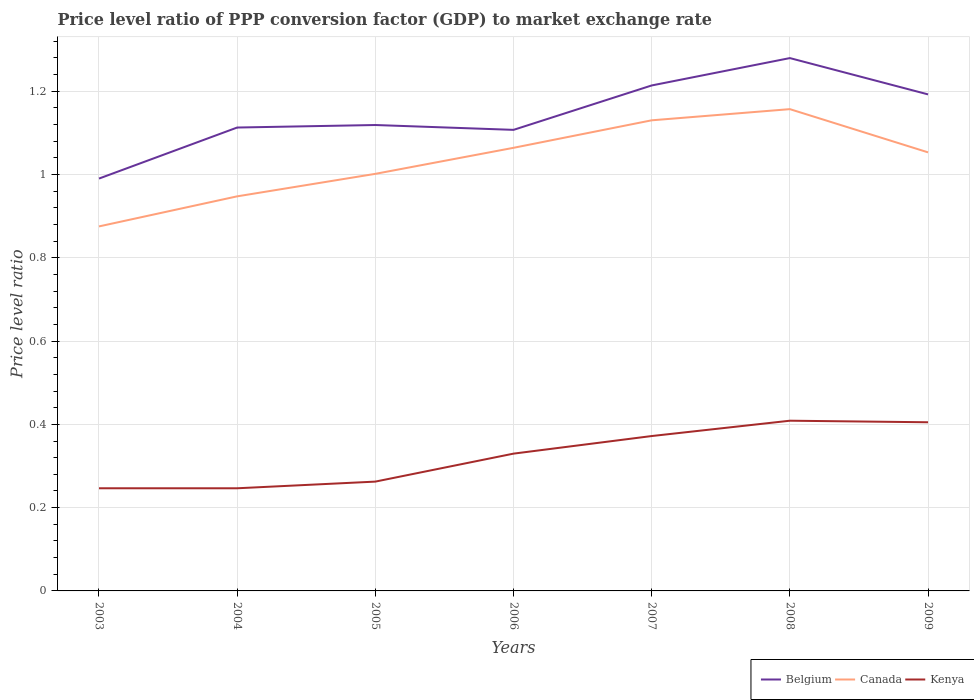Does the line corresponding to Kenya intersect with the line corresponding to Canada?
Offer a terse response. No. Is the number of lines equal to the number of legend labels?
Make the answer very short. Yes. Across all years, what is the maximum price level ratio in Canada?
Make the answer very short. 0.88. What is the total price level ratio in Belgium in the graph?
Your answer should be compact. -0.1. What is the difference between the highest and the second highest price level ratio in Kenya?
Provide a succinct answer. 0.16. Is the price level ratio in Canada strictly greater than the price level ratio in Kenya over the years?
Provide a succinct answer. No. How many years are there in the graph?
Offer a very short reply. 7. What is the difference between two consecutive major ticks on the Y-axis?
Keep it short and to the point. 0.2. Does the graph contain any zero values?
Keep it short and to the point. No. Does the graph contain grids?
Make the answer very short. Yes. How are the legend labels stacked?
Offer a terse response. Horizontal. What is the title of the graph?
Make the answer very short. Price level ratio of PPP conversion factor (GDP) to market exchange rate. What is the label or title of the Y-axis?
Make the answer very short. Price level ratio. What is the Price level ratio of Belgium in 2003?
Your response must be concise. 0.99. What is the Price level ratio in Canada in 2003?
Offer a terse response. 0.88. What is the Price level ratio in Kenya in 2003?
Provide a succinct answer. 0.25. What is the Price level ratio of Belgium in 2004?
Provide a succinct answer. 1.11. What is the Price level ratio of Canada in 2004?
Keep it short and to the point. 0.95. What is the Price level ratio of Kenya in 2004?
Make the answer very short. 0.25. What is the Price level ratio of Belgium in 2005?
Make the answer very short. 1.12. What is the Price level ratio in Canada in 2005?
Provide a short and direct response. 1. What is the Price level ratio in Kenya in 2005?
Provide a succinct answer. 0.26. What is the Price level ratio in Belgium in 2006?
Your response must be concise. 1.11. What is the Price level ratio of Canada in 2006?
Provide a succinct answer. 1.06. What is the Price level ratio of Kenya in 2006?
Give a very brief answer. 0.33. What is the Price level ratio in Belgium in 2007?
Your response must be concise. 1.21. What is the Price level ratio in Canada in 2007?
Offer a terse response. 1.13. What is the Price level ratio of Kenya in 2007?
Offer a very short reply. 0.37. What is the Price level ratio in Belgium in 2008?
Your answer should be very brief. 1.28. What is the Price level ratio in Canada in 2008?
Offer a very short reply. 1.16. What is the Price level ratio in Kenya in 2008?
Offer a terse response. 0.41. What is the Price level ratio of Belgium in 2009?
Make the answer very short. 1.19. What is the Price level ratio in Canada in 2009?
Give a very brief answer. 1.05. What is the Price level ratio in Kenya in 2009?
Keep it short and to the point. 0.4. Across all years, what is the maximum Price level ratio of Belgium?
Make the answer very short. 1.28. Across all years, what is the maximum Price level ratio in Canada?
Keep it short and to the point. 1.16. Across all years, what is the maximum Price level ratio of Kenya?
Your answer should be compact. 0.41. Across all years, what is the minimum Price level ratio of Belgium?
Give a very brief answer. 0.99. Across all years, what is the minimum Price level ratio of Canada?
Make the answer very short. 0.88. Across all years, what is the minimum Price level ratio in Kenya?
Provide a succinct answer. 0.25. What is the total Price level ratio of Belgium in the graph?
Provide a short and direct response. 8.01. What is the total Price level ratio in Canada in the graph?
Give a very brief answer. 7.23. What is the total Price level ratio of Kenya in the graph?
Offer a terse response. 2.27. What is the difference between the Price level ratio of Belgium in 2003 and that in 2004?
Make the answer very short. -0.12. What is the difference between the Price level ratio in Canada in 2003 and that in 2004?
Ensure brevity in your answer.  -0.07. What is the difference between the Price level ratio in Belgium in 2003 and that in 2005?
Keep it short and to the point. -0.13. What is the difference between the Price level ratio in Canada in 2003 and that in 2005?
Give a very brief answer. -0.13. What is the difference between the Price level ratio in Kenya in 2003 and that in 2005?
Your answer should be very brief. -0.02. What is the difference between the Price level ratio in Belgium in 2003 and that in 2006?
Provide a short and direct response. -0.12. What is the difference between the Price level ratio in Canada in 2003 and that in 2006?
Your response must be concise. -0.19. What is the difference between the Price level ratio of Kenya in 2003 and that in 2006?
Keep it short and to the point. -0.08. What is the difference between the Price level ratio in Belgium in 2003 and that in 2007?
Your answer should be very brief. -0.22. What is the difference between the Price level ratio in Canada in 2003 and that in 2007?
Keep it short and to the point. -0.25. What is the difference between the Price level ratio in Kenya in 2003 and that in 2007?
Your answer should be very brief. -0.13. What is the difference between the Price level ratio of Belgium in 2003 and that in 2008?
Make the answer very short. -0.29. What is the difference between the Price level ratio in Canada in 2003 and that in 2008?
Offer a very short reply. -0.28. What is the difference between the Price level ratio in Kenya in 2003 and that in 2008?
Your response must be concise. -0.16. What is the difference between the Price level ratio in Belgium in 2003 and that in 2009?
Your response must be concise. -0.2. What is the difference between the Price level ratio in Canada in 2003 and that in 2009?
Provide a succinct answer. -0.18. What is the difference between the Price level ratio of Kenya in 2003 and that in 2009?
Provide a succinct answer. -0.16. What is the difference between the Price level ratio in Belgium in 2004 and that in 2005?
Offer a terse response. -0.01. What is the difference between the Price level ratio in Canada in 2004 and that in 2005?
Your response must be concise. -0.05. What is the difference between the Price level ratio of Kenya in 2004 and that in 2005?
Your response must be concise. -0.02. What is the difference between the Price level ratio in Belgium in 2004 and that in 2006?
Provide a succinct answer. 0.01. What is the difference between the Price level ratio in Canada in 2004 and that in 2006?
Offer a very short reply. -0.12. What is the difference between the Price level ratio in Kenya in 2004 and that in 2006?
Ensure brevity in your answer.  -0.08. What is the difference between the Price level ratio in Belgium in 2004 and that in 2007?
Your answer should be compact. -0.1. What is the difference between the Price level ratio of Canada in 2004 and that in 2007?
Offer a very short reply. -0.18. What is the difference between the Price level ratio of Kenya in 2004 and that in 2007?
Your response must be concise. -0.13. What is the difference between the Price level ratio of Belgium in 2004 and that in 2008?
Your response must be concise. -0.17. What is the difference between the Price level ratio in Canada in 2004 and that in 2008?
Keep it short and to the point. -0.21. What is the difference between the Price level ratio in Kenya in 2004 and that in 2008?
Give a very brief answer. -0.16. What is the difference between the Price level ratio of Belgium in 2004 and that in 2009?
Give a very brief answer. -0.08. What is the difference between the Price level ratio in Canada in 2004 and that in 2009?
Offer a very short reply. -0.11. What is the difference between the Price level ratio in Kenya in 2004 and that in 2009?
Make the answer very short. -0.16. What is the difference between the Price level ratio in Belgium in 2005 and that in 2006?
Provide a short and direct response. 0.01. What is the difference between the Price level ratio of Canada in 2005 and that in 2006?
Keep it short and to the point. -0.06. What is the difference between the Price level ratio of Kenya in 2005 and that in 2006?
Provide a short and direct response. -0.07. What is the difference between the Price level ratio of Belgium in 2005 and that in 2007?
Provide a succinct answer. -0.1. What is the difference between the Price level ratio in Canada in 2005 and that in 2007?
Provide a short and direct response. -0.13. What is the difference between the Price level ratio of Kenya in 2005 and that in 2007?
Provide a short and direct response. -0.11. What is the difference between the Price level ratio of Belgium in 2005 and that in 2008?
Provide a short and direct response. -0.16. What is the difference between the Price level ratio in Canada in 2005 and that in 2008?
Your answer should be very brief. -0.16. What is the difference between the Price level ratio of Kenya in 2005 and that in 2008?
Your response must be concise. -0.15. What is the difference between the Price level ratio of Belgium in 2005 and that in 2009?
Your response must be concise. -0.07. What is the difference between the Price level ratio of Canada in 2005 and that in 2009?
Make the answer very short. -0.05. What is the difference between the Price level ratio of Kenya in 2005 and that in 2009?
Keep it short and to the point. -0.14. What is the difference between the Price level ratio in Belgium in 2006 and that in 2007?
Your answer should be compact. -0.11. What is the difference between the Price level ratio of Canada in 2006 and that in 2007?
Your answer should be very brief. -0.07. What is the difference between the Price level ratio in Kenya in 2006 and that in 2007?
Offer a terse response. -0.04. What is the difference between the Price level ratio in Belgium in 2006 and that in 2008?
Make the answer very short. -0.17. What is the difference between the Price level ratio in Canada in 2006 and that in 2008?
Keep it short and to the point. -0.09. What is the difference between the Price level ratio of Kenya in 2006 and that in 2008?
Make the answer very short. -0.08. What is the difference between the Price level ratio in Belgium in 2006 and that in 2009?
Provide a short and direct response. -0.09. What is the difference between the Price level ratio in Canada in 2006 and that in 2009?
Provide a succinct answer. 0.01. What is the difference between the Price level ratio in Kenya in 2006 and that in 2009?
Provide a succinct answer. -0.08. What is the difference between the Price level ratio in Belgium in 2007 and that in 2008?
Make the answer very short. -0.07. What is the difference between the Price level ratio of Canada in 2007 and that in 2008?
Keep it short and to the point. -0.03. What is the difference between the Price level ratio of Kenya in 2007 and that in 2008?
Give a very brief answer. -0.04. What is the difference between the Price level ratio of Belgium in 2007 and that in 2009?
Give a very brief answer. 0.02. What is the difference between the Price level ratio in Canada in 2007 and that in 2009?
Provide a succinct answer. 0.08. What is the difference between the Price level ratio of Kenya in 2007 and that in 2009?
Provide a succinct answer. -0.03. What is the difference between the Price level ratio of Belgium in 2008 and that in 2009?
Provide a short and direct response. 0.09. What is the difference between the Price level ratio in Canada in 2008 and that in 2009?
Your answer should be very brief. 0.1. What is the difference between the Price level ratio of Kenya in 2008 and that in 2009?
Offer a very short reply. 0. What is the difference between the Price level ratio of Belgium in 2003 and the Price level ratio of Canada in 2004?
Keep it short and to the point. 0.04. What is the difference between the Price level ratio of Belgium in 2003 and the Price level ratio of Kenya in 2004?
Provide a succinct answer. 0.74. What is the difference between the Price level ratio in Canada in 2003 and the Price level ratio in Kenya in 2004?
Make the answer very short. 0.63. What is the difference between the Price level ratio of Belgium in 2003 and the Price level ratio of Canada in 2005?
Offer a terse response. -0.01. What is the difference between the Price level ratio in Belgium in 2003 and the Price level ratio in Kenya in 2005?
Provide a succinct answer. 0.73. What is the difference between the Price level ratio in Canada in 2003 and the Price level ratio in Kenya in 2005?
Offer a terse response. 0.61. What is the difference between the Price level ratio of Belgium in 2003 and the Price level ratio of Canada in 2006?
Offer a terse response. -0.07. What is the difference between the Price level ratio of Belgium in 2003 and the Price level ratio of Kenya in 2006?
Offer a terse response. 0.66. What is the difference between the Price level ratio in Canada in 2003 and the Price level ratio in Kenya in 2006?
Your response must be concise. 0.55. What is the difference between the Price level ratio in Belgium in 2003 and the Price level ratio in Canada in 2007?
Your answer should be very brief. -0.14. What is the difference between the Price level ratio of Belgium in 2003 and the Price level ratio of Kenya in 2007?
Your answer should be very brief. 0.62. What is the difference between the Price level ratio of Canada in 2003 and the Price level ratio of Kenya in 2007?
Your response must be concise. 0.5. What is the difference between the Price level ratio in Belgium in 2003 and the Price level ratio in Canada in 2008?
Your answer should be compact. -0.17. What is the difference between the Price level ratio of Belgium in 2003 and the Price level ratio of Kenya in 2008?
Your answer should be very brief. 0.58. What is the difference between the Price level ratio in Canada in 2003 and the Price level ratio in Kenya in 2008?
Offer a terse response. 0.47. What is the difference between the Price level ratio in Belgium in 2003 and the Price level ratio in Canada in 2009?
Offer a terse response. -0.06. What is the difference between the Price level ratio of Belgium in 2003 and the Price level ratio of Kenya in 2009?
Give a very brief answer. 0.59. What is the difference between the Price level ratio in Canada in 2003 and the Price level ratio in Kenya in 2009?
Give a very brief answer. 0.47. What is the difference between the Price level ratio in Belgium in 2004 and the Price level ratio in Canada in 2005?
Ensure brevity in your answer.  0.11. What is the difference between the Price level ratio of Belgium in 2004 and the Price level ratio of Kenya in 2005?
Ensure brevity in your answer.  0.85. What is the difference between the Price level ratio in Canada in 2004 and the Price level ratio in Kenya in 2005?
Provide a short and direct response. 0.69. What is the difference between the Price level ratio of Belgium in 2004 and the Price level ratio of Canada in 2006?
Your answer should be compact. 0.05. What is the difference between the Price level ratio of Belgium in 2004 and the Price level ratio of Kenya in 2006?
Offer a terse response. 0.78. What is the difference between the Price level ratio in Canada in 2004 and the Price level ratio in Kenya in 2006?
Provide a succinct answer. 0.62. What is the difference between the Price level ratio in Belgium in 2004 and the Price level ratio in Canada in 2007?
Offer a very short reply. -0.02. What is the difference between the Price level ratio of Belgium in 2004 and the Price level ratio of Kenya in 2007?
Offer a very short reply. 0.74. What is the difference between the Price level ratio in Canada in 2004 and the Price level ratio in Kenya in 2007?
Give a very brief answer. 0.58. What is the difference between the Price level ratio of Belgium in 2004 and the Price level ratio of Canada in 2008?
Keep it short and to the point. -0.04. What is the difference between the Price level ratio of Belgium in 2004 and the Price level ratio of Kenya in 2008?
Your response must be concise. 0.7. What is the difference between the Price level ratio in Canada in 2004 and the Price level ratio in Kenya in 2008?
Your answer should be very brief. 0.54. What is the difference between the Price level ratio of Belgium in 2004 and the Price level ratio of Canada in 2009?
Offer a very short reply. 0.06. What is the difference between the Price level ratio in Belgium in 2004 and the Price level ratio in Kenya in 2009?
Give a very brief answer. 0.71. What is the difference between the Price level ratio of Canada in 2004 and the Price level ratio of Kenya in 2009?
Provide a succinct answer. 0.54. What is the difference between the Price level ratio of Belgium in 2005 and the Price level ratio of Canada in 2006?
Keep it short and to the point. 0.05. What is the difference between the Price level ratio of Belgium in 2005 and the Price level ratio of Kenya in 2006?
Offer a very short reply. 0.79. What is the difference between the Price level ratio in Canada in 2005 and the Price level ratio in Kenya in 2006?
Provide a short and direct response. 0.67. What is the difference between the Price level ratio of Belgium in 2005 and the Price level ratio of Canada in 2007?
Keep it short and to the point. -0.01. What is the difference between the Price level ratio in Belgium in 2005 and the Price level ratio in Kenya in 2007?
Offer a terse response. 0.75. What is the difference between the Price level ratio of Canada in 2005 and the Price level ratio of Kenya in 2007?
Your response must be concise. 0.63. What is the difference between the Price level ratio of Belgium in 2005 and the Price level ratio of Canada in 2008?
Your answer should be very brief. -0.04. What is the difference between the Price level ratio of Belgium in 2005 and the Price level ratio of Kenya in 2008?
Your answer should be compact. 0.71. What is the difference between the Price level ratio of Canada in 2005 and the Price level ratio of Kenya in 2008?
Your response must be concise. 0.59. What is the difference between the Price level ratio of Belgium in 2005 and the Price level ratio of Canada in 2009?
Keep it short and to the point. 0.07. What is the difference between the Price level ratio of Belgium in 2005 and the Price level ratio of Kenya in 2009?
Ensure brevity in your answer.  0.71. What is the difference between the Price level ratio of Canada in 2005 and the Price level ratio of Kenya in 2009?
Ensure brevity in your answer.  0.6. What is the difference between the Price level ratio of Belgium in 2006 and the Price level ratio of Canada in 2007?
Your response must be concise. -0.02. What is the difference between the Price level ratio of Belgium in 2006 and the Price level ratio of Kenya in 2007?
Give a very brief answer. 0.74. What is the difference between the Price level ratio in Canada in 2006 and the Price level ratio in Kenya in 2007?
Ensure brevity in your answer.  0.69. What is the difference between the Price level ratio of Belgium in 2006 and the Price level ratio of Canada in 2008?
Make the answer very short. -0.05. What is the difference between the Price level ratio of Belgium in 2006 and the Price level ratio of Kenya in 2008?
Keep it short and to the point. 0.7. What is the difference between the Price level ratio in Canada in 2006 and the Price level ratio in Kenya in 2008?
Make the answer very short. 0.66. What is the difference between the Price level ratio of Belgium in 2006 and the Price level ratio of Canada in 2009?
Your answer should be compact. 0.05. What is the difference between the Price level ratio in Belgium in 2006 and the Price level ratio in Kenya in 2009?
Your answer should be very brief. 0.7. What is the difference between the Price level ratio of Canada in 2006 and the Price level ratio of Kenya in 2009?
Keep it short and to the point. 0.66. What is the difference between the Price level ratio of Belgium in 2007 and the Price level ratio of Canada in 2008?
Ensure brevity in your answer.  0.06. What is the difference between the Price level ratio of Belgium in 2007 and the Price level ratio of Kenya in 2008?
Make the answer very short. 0.81. What is the difference between the Price level ratio of Canada in 2007 and the Price level ratio of Kenya in 2008?
Keep it short and to the point. 0.72. What is the difference between the Price level ratio in Belgium in 2007 and the Price level ratio in Canada in 2009?
Your answer should be compact. 0.16. What is the difference between the Price level ratio in Belgium in 2007 and the Price level ratio in Kenya in 2009?
Your response must be concise. 0.81. What is the difference between the Price level ratio of Canada in 2007 and the Price level ratio of Kenya in 2009?
Ensure brevity in your answer.  0.73. What is the difference between the Price level ratio in Belgium in 2008 and the Price level ratio in Canada in 2009?
Ensure brevity in your answer.  0.23. What is the difference between the Price level ratio of Belgium in 2008 and the Price level ratio of Kenya in 2009?
Your response must be concise. 0.87. What is the difference between the Price level ratio in Canada in 2008 and the Price level ratio in Kenya in 2009?
Give a very brief answer. 0.75. What is the average Price level ratio in Belgium per year?
Give a very brief answer. 1.14. What is the average Price level ratio in Canada per year?
Make the answer very short. 1.03. What is the average Price level ratio of Kenya per year?
Provide a succinct answer. 0.32. In the year 2003, what is the difference between the Price level ratio of Belgium and Price level ratio of Canada?
Your response must be concise. 0.11. In the year 2003, what is the difference between the Price level ratio of Belgium and Price level ratio of Kenya?
Provide a short and direct response. 0.74. In the year 2003, what is the difference between the Price level ratio of Canada and Price level ratio of Kenya?
Provide a succinct answer. 0.63. In the year 2004, what is the difference between the Price level ratio in Belgium and Price level ratio in Canada?
Keep it short and to the point. 0.17. In the year 2004, what is the difference between the Price level ratio of Belgium and Price level ratio of Kenya?
Your answer should be compact. 0.87. In the year 2004, what is the difference between the Price level ratio of Canada and Price level ratio of Kenya?
Provide a succinct answer. 0.7. In the year 2005, what is the difference between the Price level ratio of Belgium and Price level ratio of Canada?
Make the answer very short. 0.12. In the year 2005, what is the difference between the Price level ratio of Belgium and Price level ratio of Kenya?
Offer a very short reply. 0.86. In the year 2005, what is the difference between the Price level ratio of Canada and Price level ratio of Kenya?
Provide a short and direct response. 0.74. In the year 2006, what is the difference between the Price level ratio of Belgium and Price level ratio of Canada?
Provide a short and direct response. 0.04. In the year 2006, what is the difference between the Price level ratio in Belgium and Price level ratio in Kenya?
Offer a very short reply. 0.78. In the year 2006, what is the difference between the Price level ratio in Canada and Price level ratio in Kenya?
Your answer should be very brief. 0.73. In the year 2007, what is the difference between the Price level ratio of Belgium and Price level ratio of Canada?
Ensure brevity in your answer.  0.08. In the year 2007, what is the difference between the Price level ratio of Belgium and Price level ratio of Kenya?
Make the answer very short. 0.84. In the year 2007, what is the difference between the Price level ratio of Canada and Price level ratio of Kenya?
Give a very brief answer. 0.76. In the year 2008, what is the difference between the Price level ratio of Belgium and Price level ratio of Canada?
Offer a very short reply. 0.12. In the year 2008, what is the difference between the Price level ratio of Belgium and Price level ratio of Kenya?
Keep it short and to the point. 0.87. In the year 2008, what is the difference between the Price level ratio of Canada and Price level ratio of Kenya?
Keep it short and to the point. 0.75. In the year 2009, what is the difference between the Price level ratio in Belgium and Price level ratio in Canada?
Give a very brief answer. 0.14. In the year 2009, what is the difference between the Price level ratio of Belgium and Price level ratio of Kenya?
Ensure brevity in your answer.  0.79. In the year 2009, what is the difference between the Price level ratio in Canada and Price level ratio in Kenya?
Make the answer very short. 0.65. What is the ratio of the Price level ratio in Belgium in 2003 to that in 2004?
Ensure brevity in your answer.  0.89. What is the ratio of the Price level ratio in Canada in 2003 to that in 2004?
Provide a succinct answer. 0.92. What is the ratio of the Price level ratio of Kenya in 2003 to that in 2004?
Ensure brevity in your answer.  1. What is the ratio of the Price level ratio in Belgium in 2003 to that in 2005?
Your answer should be compact. 0.89. What is the ratio of the Price level ratio in Canada in 2003 to that in 2005?
Your response must be concise. 0.87. What is the ratio of the Price level ratio in Kenya in 2003 to that in 2005?
Offer a terse response. 0.94. What is the ratio of the Price level ratio in Belgium in 2003 to that in 2006?
Offer a very short reply. 0.89. What is the ratio of the Price level ratio of Canada in 2003 to that in 2006?
Your answer should be very brief. 0.82. What is the ratio of the Price level ratio of Kenya in 2003 to that in 2006?
Offer a very short reply. 0.75. What is the ratio of the Price level ratio in Belgium in 2003 to that in 2007?
Your answer should be compact. 0.82. What is the ratio of the Price level ratio of Canada in 2003 to that in 2007?
Provide a succinct answer. 0.77. What is the ratio of the Price level ratio of Kenya in 2003 to that in 2007?
Keep it short and to the point. 0.66. What is the ratio of the Price level ratio of Belgium in 2003 to that in 2008?
Your response must be concise. 0.77. What is the ratio of the Price level ratio in Canada in 2003 to that in 2008?
Ensure brevity in your answer.  0.76. What is the ratio of the Price level ratio of Kenya in 2003 to that in 2008?
Provide a succinct answer. 0.6. What is the ratio of the Price level ratio of Belgium in 2003 to that in 2009?
Offer a terse response. 0.83. What is the ratio of the Price level ratio of Canada in 2003 to that in 2009?
Ensure brevity in your answer.  0.83. What is the ratio of the Price level ratio in Kenya in 2003 to that in 2009?
Offer a terse response. 0.61. What is the ratio of the Price level ratio of Belgium in 2004 to that in 2005?
Keep it short and to the point. 0.99. What is the ratio of the Price level ratio of Canada in 2004 to that in 2005?
Ensure brevity in your answer.  0.95. What is the ratio of the Price level ratio of Kenya in 2004 to that in 2005?
Offer a terse response. 0.94. What is the ratio of the Price level ratio in Belgium in 2004 to that in 2006?
Your answer should be very brief. 1.01. What is the ratio of the Price level ratio in Canada in 2004 to that in 2006?
Provide a short and direct response. 0.89. What is the ratio of the Price level ratio of Kenya in 2004 to that in 2006?
Give a very brief answer. 0.75. What is the ratio of the Price level ratio in Belgium in 2004 to that in 2007?
Provide a succinct answer. 0.92. What is the ratio of the Price level ratio of Canada in 2004 to that in 2007?
Your answer should be compact. 0.84. What is the ratio of the Price level ratio in Kenya in 2004 to that in 2007?
Offer a very short reply. 0.66. What is the ratio of the Price level ratio in Belgium in 2004 to that in 2008?
Provide a succinct answer. 0.87. What is the ratio of the Price level ratio of Canada in 2004 to that in 2008?
Provide a succinct answer. 0.82. What is the ratio of the Price level ratio of Kenya in 2004 to that in 2008?
Keep it short and to the point. 0.6. What is the ratio of the Price level ratio of Belgium in 2004 to that in 2009?
Offer a very short reply. 0.93. What is the ratio of the Price level ratio of Canada in 2004 to that in 2009?
Ensure brevity in your answer.  0.9. What is the ratio of the Price level ratio in Kenya in 2004 to that in 2009?
Provide a short and direct response. 0.61. What is the ratio of the Price level ratio of Belgium in 2005 to that in 2006?
Keep it short and to the point. 1.01. What is the ratio of the Price level ratio in Canada in 2005 to that in 2006?
Your answer should be compact. 0.94. What is the ratio of the Price level ratio of Kenya in 2005 to that in 2006?
Your answer should be compact. 0.8. What is the ratio of the Price level ratio in Belgium in 2005 to that in 2007?
Your answer should be very brief. 0.92. What is the ratio of the Price level ratio in Canada in 2005 to that in 2007?
Provide a short and direct response. 0.89. What is the ratio of the Price level ratio in Kenya in 2005 to that in 2007?
Offer a very short reply. 0.71. What is the ratio of the Price level ratio in Belgium in 2005 to that in 2008?
Keep it short and to the point. 0.87. What is the ratio of the Price level ratio in Canada in 2005 to that in 2008?
Give a very brief answer. 0.87. What is the ratio of the Price level ratio in Kenya in 2005 to that in 2008?
Offer a terse response. 0.64. What is the ratio of the Price level ratio of Belgium in 2005 to that in 2009?
Your response must be concise. 0.94. What is the ratio of the Price level ratio of Canada in 2005 to that in 2009?
Make the answer very short. 0.95. What is the ratio of the Price level ratio of Kenya in 2005 to that in 2009?
Offer a very short reply. 0.65. What is the ratio of the Price level ratio of Belgium in 2006 to that in 2007?
Ensure brevity in your answer.  0.91. What is the ratio of the Price level ratio of Canada in 2006 to that in 2007?
Provide a succinct answer. 0.94. What is the ratio of the Price level ratio of Kenya in 2006 to that in 2007?
Offer a terse response. 0.89. What is the ratio of the Price level ratio of Belgium in 2006 to that in 2008?
Keep it short and to the point. 0.87. What is the ratio of the Price level ratio in Canada in 2006 to that in 2008?
Offer a terse response. 0.92. What is the ratio of the Price level ratio in Kenya in 2006 to that in 2008?
Keep it short and to the point. 0.81. What is the ratio of the Price level ratio of Belgium in 2006 to that in 2009?
Offer a terse response. 0.93. What is the ratio of the Price level ratio in Canada in 2006 to that in 2009?
Your answer should be very brief. 1.01. What is the ratio of the Price level ratio of Kenya in 2006 to that in 2009?
Your response must be concise. 0.81. What is the ratio of the Price level ratio of Belgium in 2007 to that in 2008?
Provide a succinct answer. 0.95. What is the ratio of the Price level ratio in Canada in 2007 to that in 2008?
Ensure brevity in your answer.  0.98. What is the ratio of the Price level ratio of Kenya in 2007 to that in 2008?
Give a very brief answer. 0.91. What is the ratio of the Price level ratio in Belgium in 2007 to that in 2009?
Give a very brief answer. 1.02. What is the ratio of the Price level ratio of Canada in 2007 to that in 2009?
Your answer should be compact. 1.07. What is the ratio of the Price level ratio in Kenya in 2007 to that in 2009?
Give a very brief answer. 0.92. What is the ratio of the Price level ratio of Belgium in 2008 to that in 2009?
Give a very brief answer. 1.07. What is the ratio of the Price level ratio of Canada in 2008 to that in 2009?
Make the answer very short. 1.1. What is the ratio of the Price level ratio in Kenya in 2008 to that in 2009?
Make the answer very short. 1.01. What is the difference between the highest and the second highest Price level ratio of Belgium?
Provide a short and direct response. 0.07. What is the difference between the highest and the second highest Price level ratio of Canada?
Provide a succinct answer. 0.03. What is the difference between the highest and the second highest Price level ratio of Kenya?
Your answer should be very brief. 0. What is the difference between the highest and the lowest Price level ratio of Belgium?
Offer a very short reply. 0.29. What is the difference between the highest and the lowest Price level ratio in Canada?
Offer a very short reply. 0.28. What is the difference between the highest and the lowest Price level ratio in Kenya?
Keep it short and to the point. 0.16. 